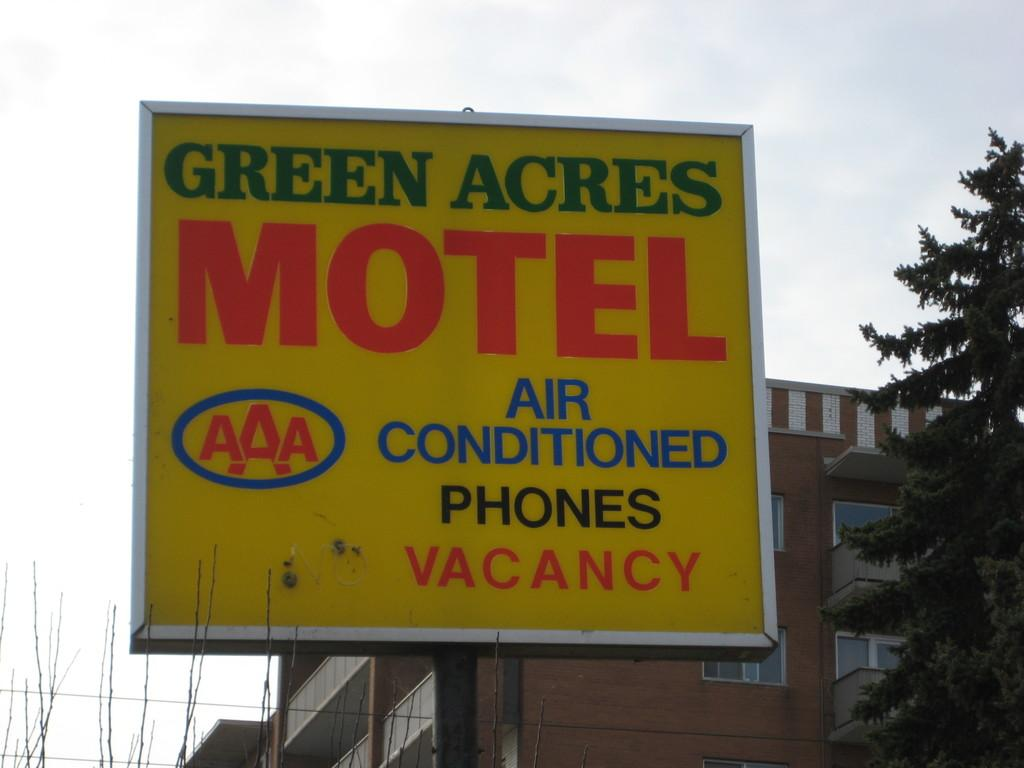<image>
Create a compact narrative representing the image presented. A motel named Green Acres offers phones and air conditioning and currently has vacancies. 